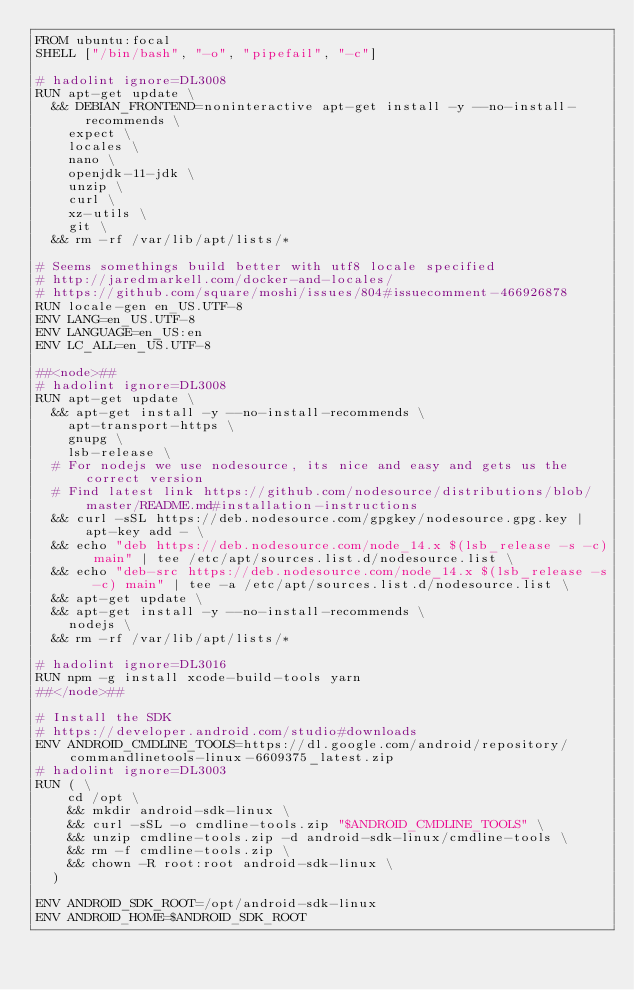Convert code to text. <code><loc_0><loc_0><loc_500><loc_500><_Dockerfile_>FROM ubuntu:focal
SHELL ["/bin/bash", "-o", "pipefail", "-c"]

# hadolint ignore=DL3008
RUN apt-get update \
  && DEBIAN_FRONTEND=noninteractive apt-get install -y --no-install-recommends \
    expect \
    locales \
    nano \
    openjdk-11-jdk \
    unzip \
    curl \
    xz-utils \
    git \
  && rm -rf /var/lib/apt/lists/*

# Seems somethings build better with utf8 locale specified
# http://jaredmarkell.com/docker-and-locales/
# https://github.com/square/moshi/issues/804#issuecomment-466926878
RUN locale-gen en_US.UTF-8
ENV LANG=en_US.UTF-8
ENV LANGUAGE=en_US:en
ENV LC_ALL=en_US.UTF-8

##<node>##
# hadolint ignore=DL3008
RUN apt-get update \
  && apt-get install -y --no-install-recommends \
    apt-transport-https \
    gnupg \
    lsb-release \
  # For nodejs we use nodesource, its nice and easy and gets us the correct version
  # Find latest link https://github.com/nodesource/distributions/blob/master/README.md#installation-instructions
  && curl -sSL https://deb.nodesource.com/gpgkey/nodesource.gpg.key | apt-key add - \
  && echo "deb https://deb.nodesource.com/node_14.x $(lsb_release -s -c) main" | tee /etc/apt/sources.list.d/nodesource.list \
  && echo "deb-src https://deb.nodesource.com/node_14.x $(lsb_release -s -c) main" | tee -a /etc/apt/sources.list.d/nodesource.list \
  && apt-get update \
  && apt-get install -y --no-install-recommends \
    nodejs \
  && rm -rf /var/lib/apt/lists/*

# hadolint ignore=DL3016
RUN npm -g install xcode-build-tools yarn
##</node>##

# Install the SDK
# https://developer.android.com/studio#downloads
ENV ANDROID_CMDLINE_TOOLS=https://dl.google.com/android/repository/commandlinetools-linux-6609375_latest.zip
# hadolint ignore=DL3003
RUN ( \
    cd /opt \
    && mkdir android-sdk-linux \
    && curl -sSL -o cmdline-tools.zip "$ANDROID_CMDLINE_TOOLS" \
    && unzip cmdline-tools.zip -d android-sdk-linux/cmdline-tools \
    && rm -f cmdline-tools.zip \
    && chown -R root:root android-sdk-linux \
  )

ENV ANDROID_SDK_ROOT=/opt/android-sdk-linux
ENV ANDROID_HOME=$ANDROID_SDK_ROOT</code> 